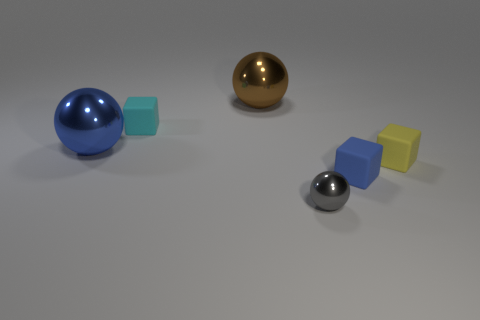Add 4 tiny purple things. How many objects exist? 10 Subtract 0 blue cylinders. How many objects are left? 6 Subtract all tiny blocks. Subtract all small spheres. How many objects are left? 2 Add 6 large brown spheres. How many large brown spheres are left? 7 Add 6 green rubber cylinders. How many green rubber cylinders exist? 6 